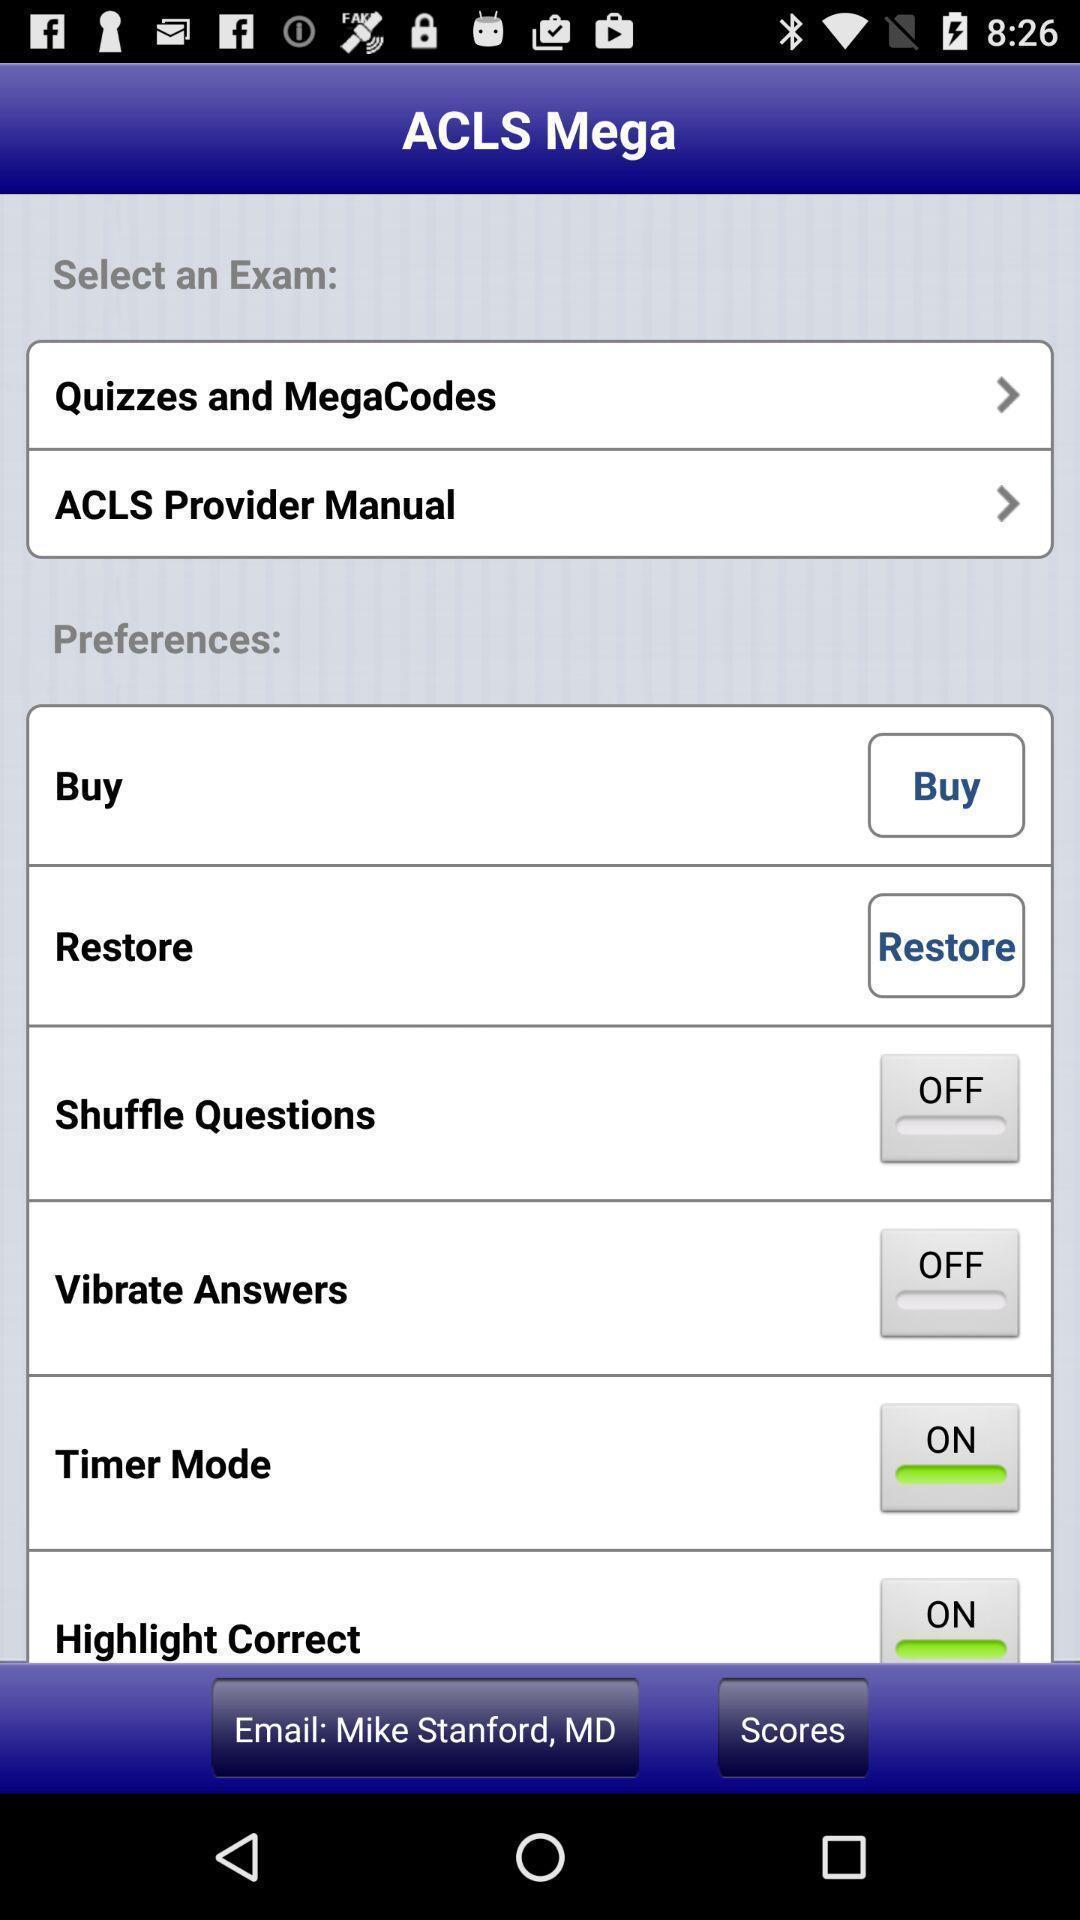Explain what's happening in this screen capture. Screen displaying the multiple options. 